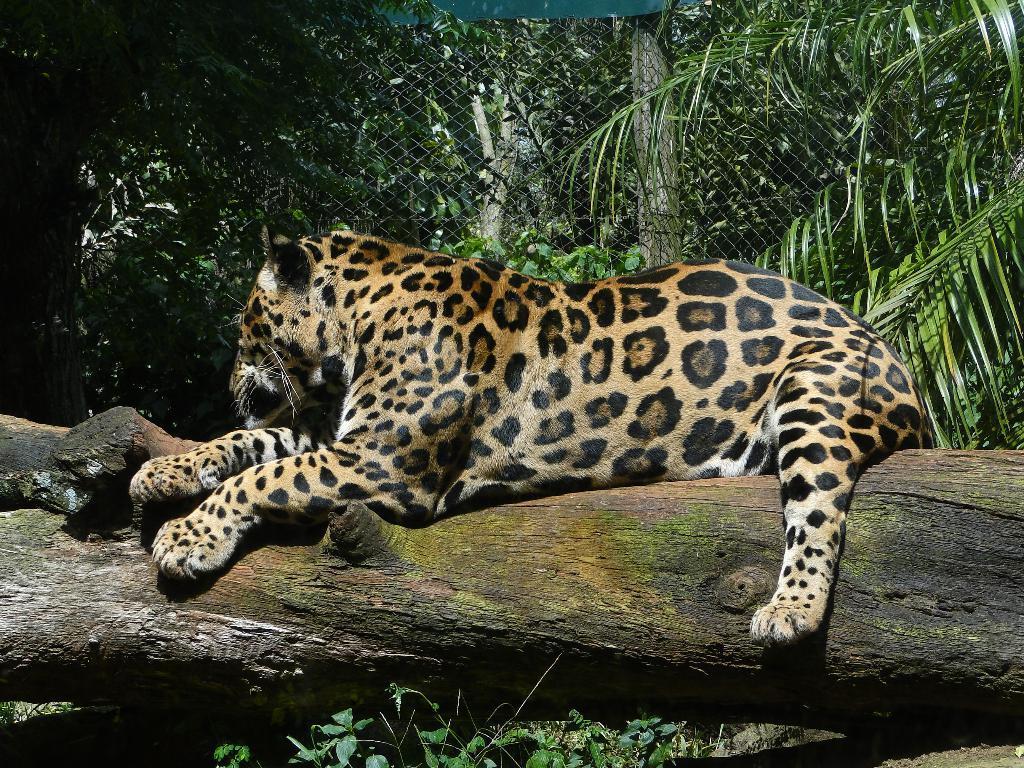How would you summarize this image in a sentence or two? This picture shows few trees and a metal fence and we see leopard on the tree bark. 